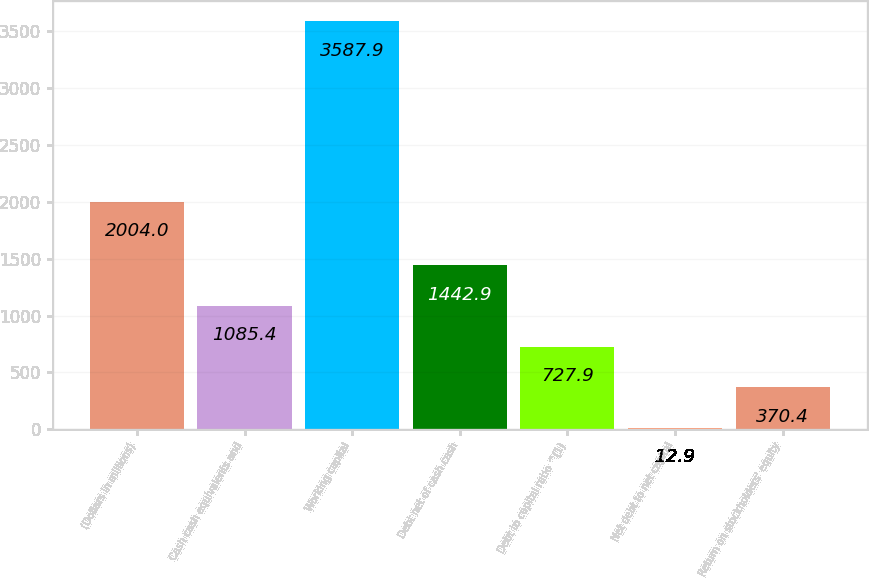Convert chart to OTSL. <chart><loc_0><loc_0><loc_500><loc_500><bar_chart><fcel>(Dollars in millions)<fcel>Cash cash equivalents and<fcel>Working capital<fcel>Debt net of cash cash<fcel>Debt to capital ratio ^(1)<fcel>Net debt to net capital<fcel>Return on stockholders' equity<nl><fcel>2004<fcel>1085.4<fcel>3587.9<fcel>1442.9<fcel>727.9<fcel>12.9<fcel>370.4<nl></chart> 